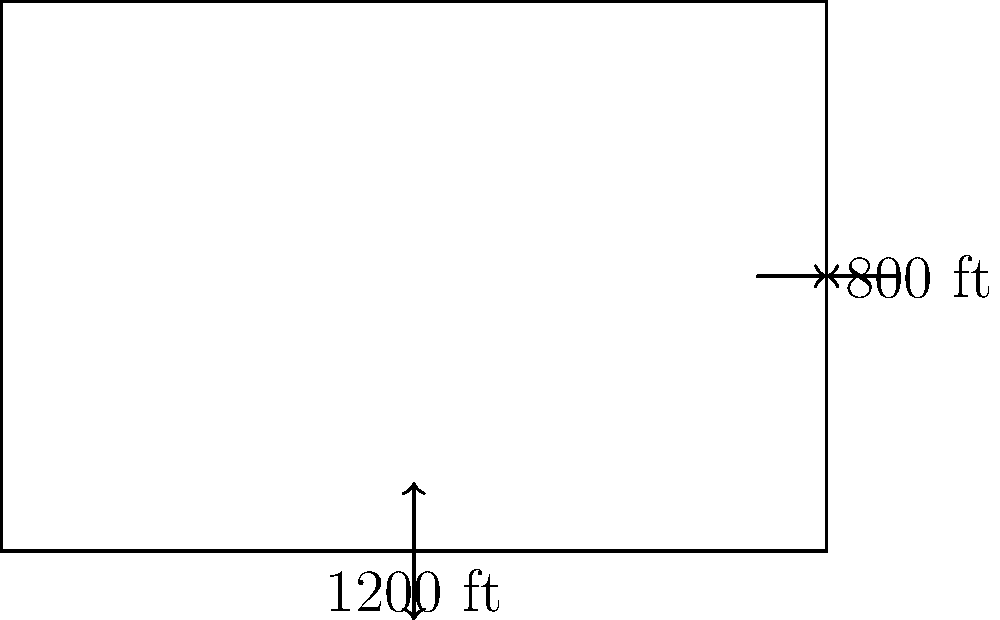As a public affairs officer for the 439th Airlift Wing, you need to report on a new rectangular airfield. The airfield measures 1200 feet in length and 800 feet in width. What is the total area of the airfield in square feet? To calculate the area of a rectangular airfield, we need to multiply its length by its width. Let's break it down step-by-step:

1. Identify the given dimensions:
   Length = 1200 feet
   Width = 800 feet

2. Apply the formula for the area of a rectangle:
   Area = Length × Width

3. Substitute the values into the formula:
   Area = 1200 feet × 800 feet

4. Perform the multiplication:
   Area = 960,000 square feet

Therefore, the total area of the rectangular airfield is 960,000 square feet.
Answer: 960,000 sq ft 